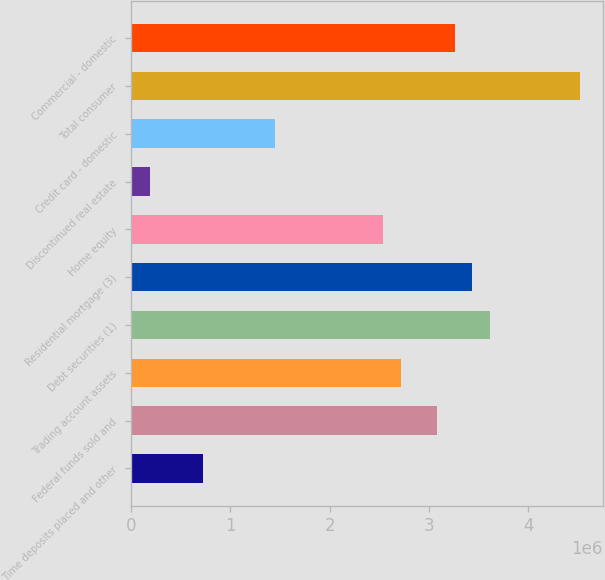<chart> <loc_0><loc_0><loc_500><loc_500><bar_chart><fcel>Time deposits placed and other<fcel>Federal funds sold and<fcel>Trading account assets<fcel>Debt securities (1)<fcel>Residential mortgage (3)<fcel>Home equity<fcel>Discontinued real estate<fcel>Credit card - domestic<fcel>Total consumer<fcel>Commercial - domestic<nl><fcel>729220<fcel>3.0752e+06<fcel>2.71428e+06<fcel>3.61658e+06<fcel>3.43612e+06<fcel>2.53382e+06<fcel>187839<fcel>1.45106e+06<fcel>4.51888e+06<fcel>3.25566e+06<nl></chart> 